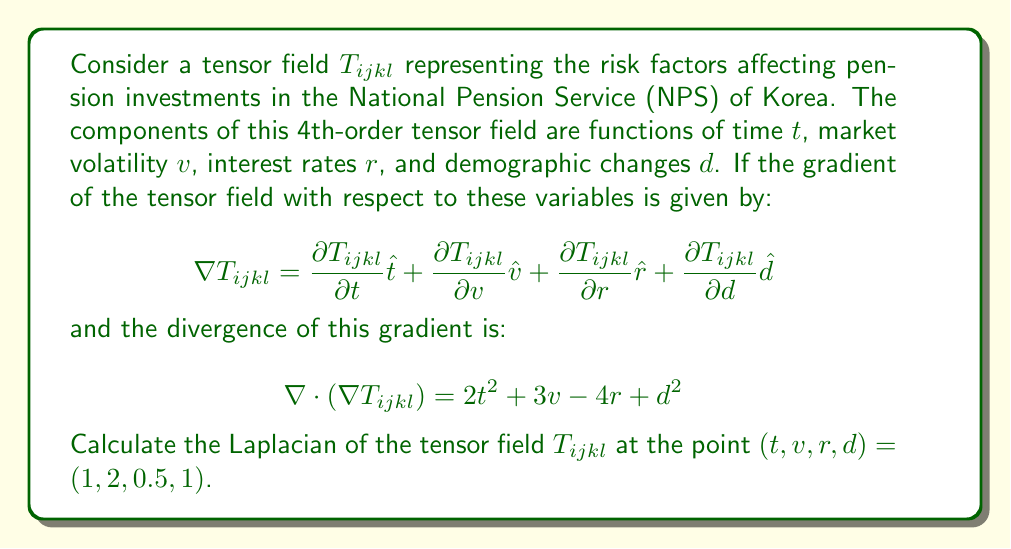Could you help me with this problem? To solve this problem, we need to follow these steps:

1) Recall that the Laplacian of a tensor field is the divergence of the gradient of that field. In mathematical notation:

   $$\nabla^2 T_{ijkl} = \nabla \cdot (\nabla T_{ijkl})$$

2) We are given the divergence of the gradient directly:

   $$\nabla \cdot (\nabla T_{ijkl}) = 2t^2 + 3v - 4r + d^2$$

3) This equation represents the Laplacian of our tensor field $T_{ijkl}$.

4) To find the value of the Laplacian at the point $(t,v,r,d) = (1,2,0.5,1)$, we simply need to substitute these values into the equation:

   $$\nabla^2 T_{ijkl} = 2(1)^2 + 3(2) - 4(0.5) + (1)^2$$

5) Let's calculate each term:
   - $2(1)^2 = 2$
   - $3(2) = 6$
   - $-4(0.5) = -2$
   - $(1)^2 = 1$

6) Sum up all the terms:

   $$\nabla^2 T_{ijkl} = 2 + 6 - 2 + 1 = 7$$

Therefore, the Laplacian of the tensor field $T_{ijkl}$ at the point $(1,2,0.5,1)$ is 7.
Answer: 7 